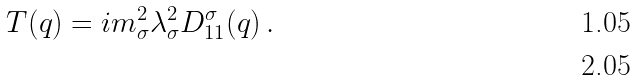Convert formula to latex. <formula><loc_0><loc_0><loc_500><loc_500>T ( q ) = i m _ { \sigma } ^ { 2 } \lambda _ { \sigma } ^ { 2 } D _ { 1 1 } ^ { \sigma } ( q ) \, . \\</formula> 